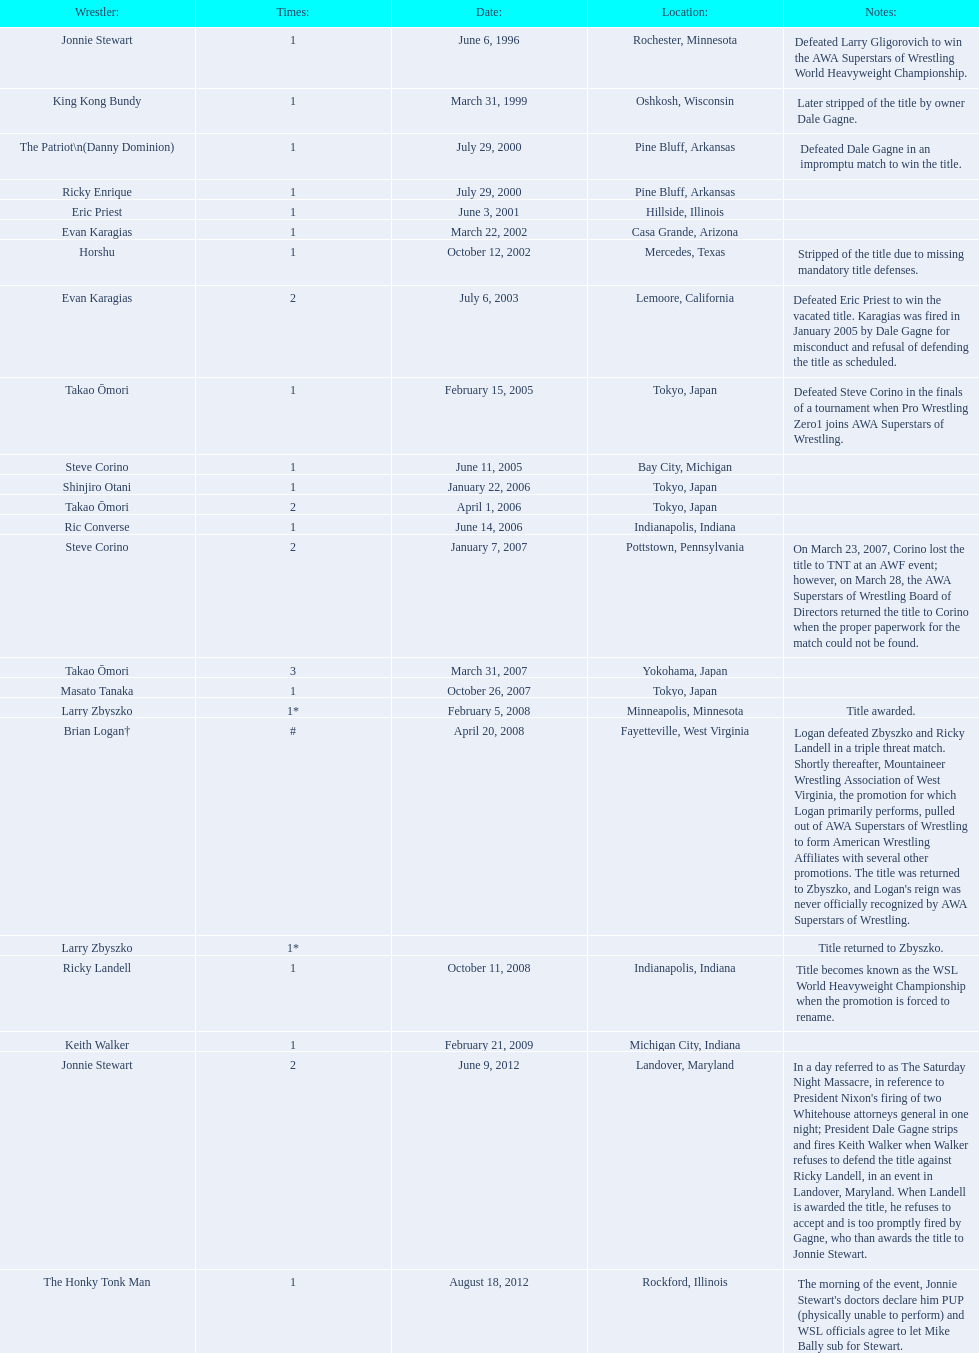Who are all of the wrestlers? Jonnie Stewart, King Kong Bundy, The Patriot\n(Danny Dominion), Ricky Enrique, Eric Priest, Evan Karagias, Horshu, Evan Karagias, Takao Ōmori, Steve Corino, Shinjiro Otani, Takao Ōmori, Ric Converse, Steve Corino, Takao Ōmori, Masato Tanaka, Larry Zbyszko, Brian Logan†, Larry Zbyszko, Ricky Landell, Keith Walker, Jonnie Stewart, The Honky Tonk Man. Where are they from? Rochester, Minnesota, Oshkosh, Wisconsin, Pine Bluff, Arkansas, Pine Bluff, Arkansas, Hillside, Illinois, Casa Grande, Arizona, Mercedes, Texas, Lemoore, California, Tokyo, Japan, Bay City, Michigan, Tokyo, Japan, Tokyo, Japan, Indianapolis, Indiana, Pottstown, Pennsylvania, Yokohama, Japan, Tokyo, Japan, Minneapolis, Minnesota, Fayetteville, West Virginia, , Indianapolis, Indiana, Michigan City, Indiana, Landover, Maryland, Rockford, Illinois. And which of them is from texas? Horshu. 